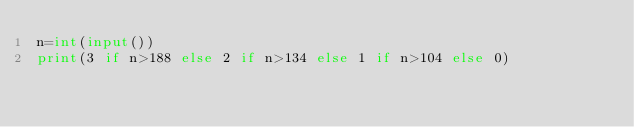<code> <loc_0><loc_0><loc_500><loc_500><_Python_>n=int(input())
print(3 if n>188 else 2 if n>134 else 1 if n>104 else 0)</code> 